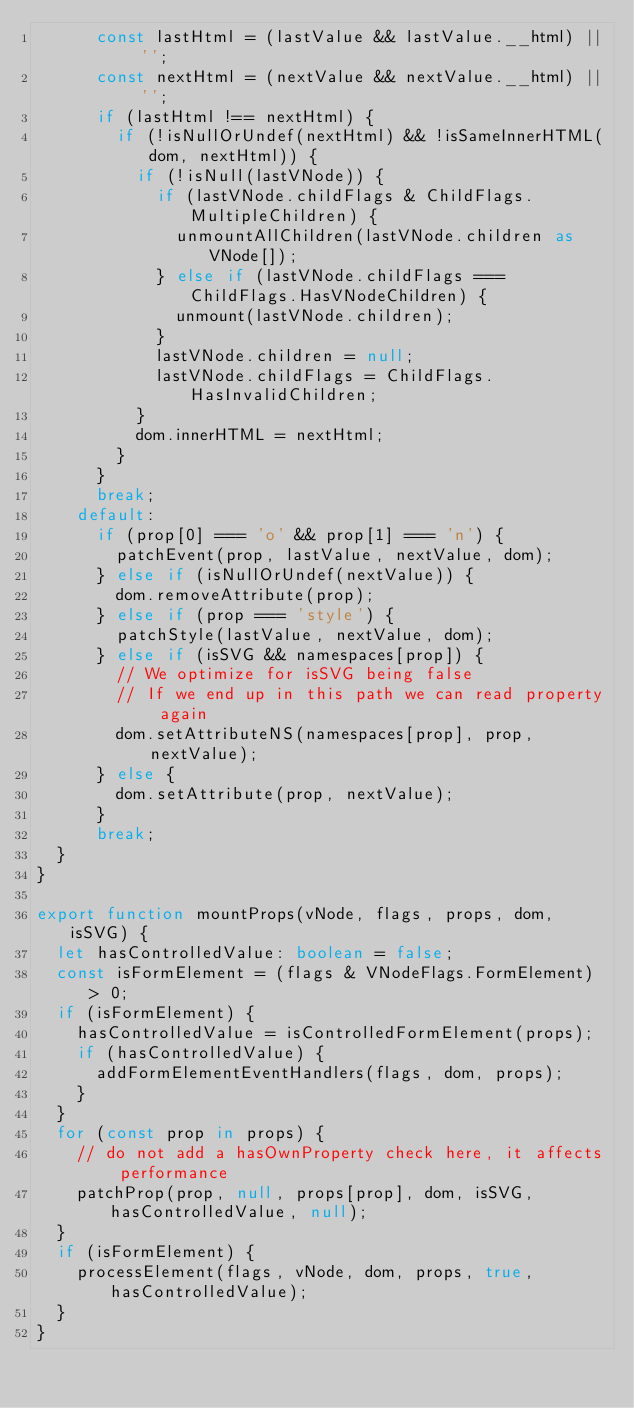<code> <loc_0><loc_0><loc_500><loc_500><_TypeScript_>      const lastHtml = (lastValue && lastValue.__html) || '';
      const nextHtml = (nextValue && nextValue.__html) || '';
      if (lastHtml !== nextHtml) {
        if (!isNullOrUndef(nextHtml) && !isSameInnerHTML(dom, nextHtml)) {
          if (!isNull(lastVNode)) {
            if (lastVNode.childFlags & ChildFlags.MultipleChildren) {
              unmountAllChildren(lastVNode.children as VNode[]);
            } else if (lastVNode.childFlags === ChildFlags.HasVNodeChildren) {
              unmount(lastVNode.children);
            }
            lastVNode.children = null;
            lastVNode.childFlags = ChildFlags.HasInvalidChildren;
          }
          dom.innerHTML = nextHtml;
        }
      }
      break;
    default:
      if (prop[0] === 'o' && prop[1] === 'n') {
        patchEvent(prop, lastValue, nextValue, dom);
      } else if (isNullOrUndef(nextValue)) {
        dom.removeAttribute(prop);
      } else if (prop === 'style') {
        patchStyle(lastValue, nextValue, dom);
      } else if (isSVG && namespaces[prop]) {
        // We optimize for isSVG being false
        // If we end up in this path we can read property again
        dom.setAttributeNS(namespaces[prop], prop, nextValue);
      } else {
        dom.setAttribute(prop, nextValue);
      }
      break;
  }
}

export function mountProps(vNode, flags, props, dom, isSVG) {
  let hasControlledValue: boolean = false;
  const isFormElement = (flags & VNodeFlags.FormElement) > 0;
  if (isFormElement) {
    hasControlledValue = isControlledFormElement(props);
    if (hasControlledValue) {
      addFormElementEventHandlers(flags, dom, props);
    }
  }
  for (const prop in props) {
    // do not add a hasOwnProperty check here, it affects performance
    patchProp(prop, null, props[prop], dom, isSVG, hasControlledValue, null);
  }
  if (isFormElement) {
    processElement(flags, vNode, dom, props, true, hasControlledValue);
  }
}
</code> 